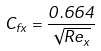<formula> <loc_0><loc_0><loc_500><loc_500>C _ { f x } = \frac { 0 . 6 6 4 } { \sqrt { R e _ { x } } }</formula> 